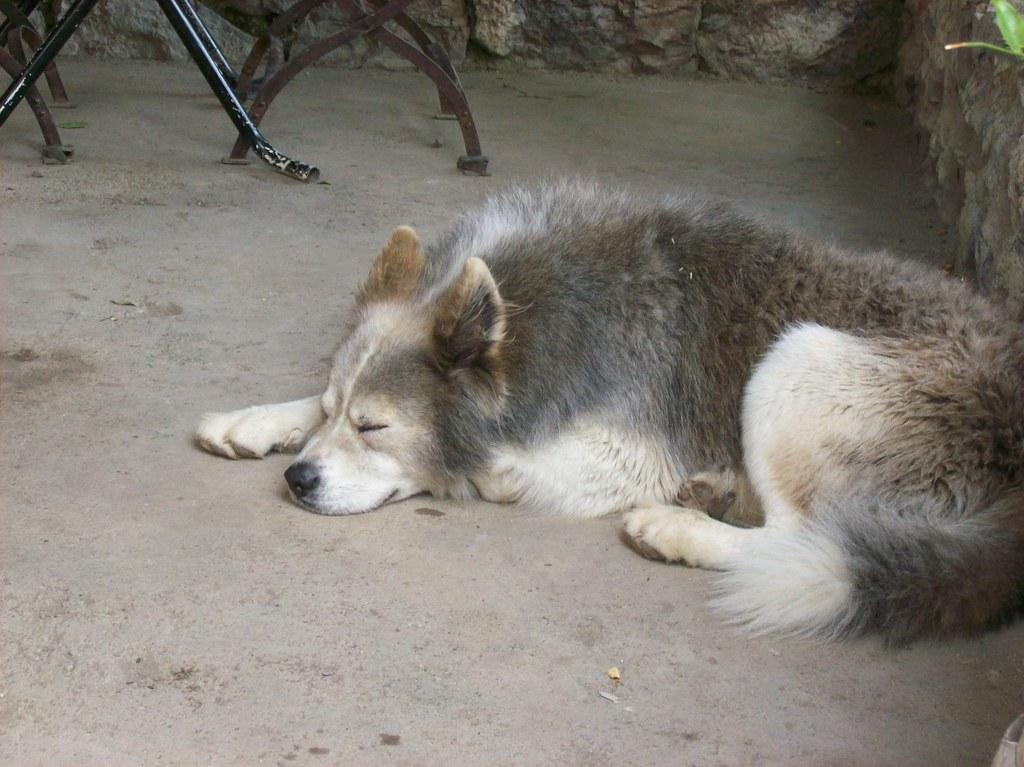What animal can be seen on the ground in the image? There is a dog on the ground in the image. What type of structure is present in the image? There is a wall in the image. What object made of metal can be seen in the image? There is an iron rod in the image. How much was the payment for the dog's patch in the image? There is no indication of a payment or a patch on the dog in the image. 